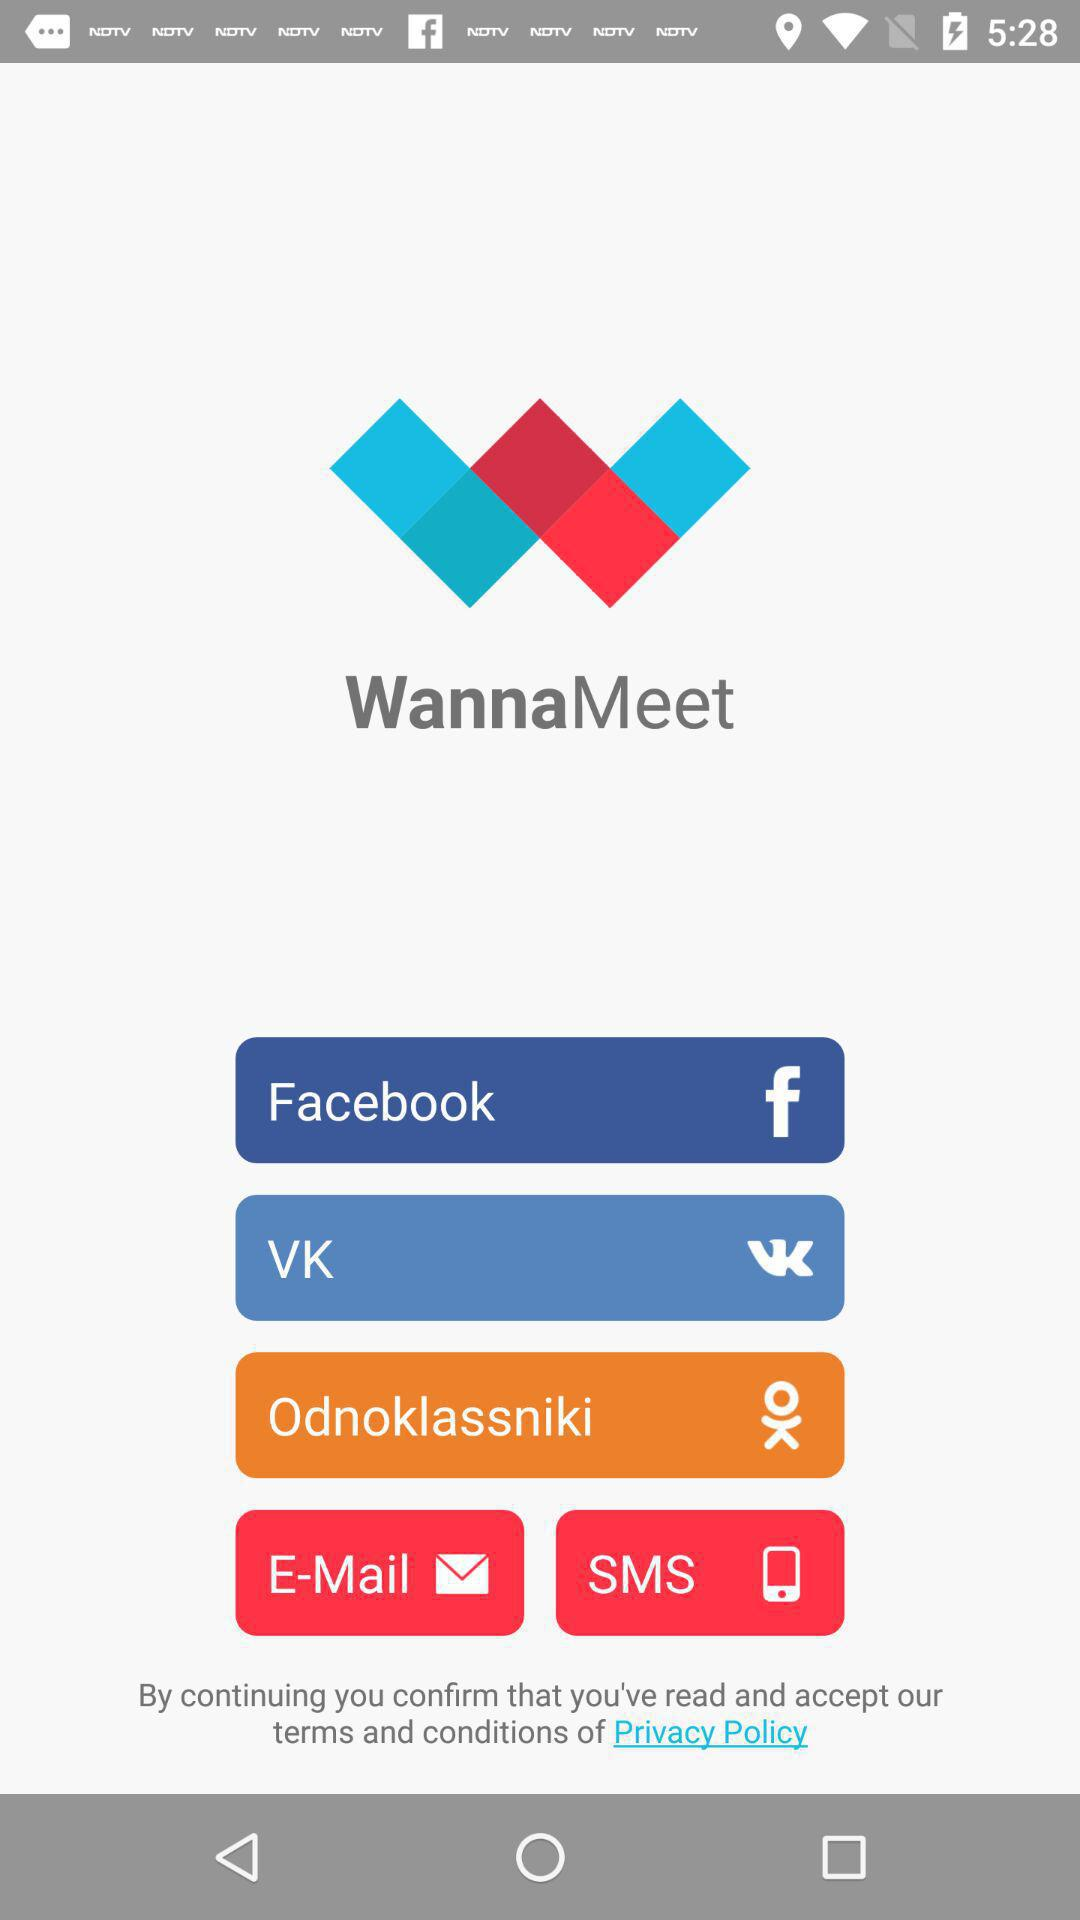Which are the different login options? The different login options are "Facebook", "VK", "Odnoklassniki", "E-Mail" and "SMS". 